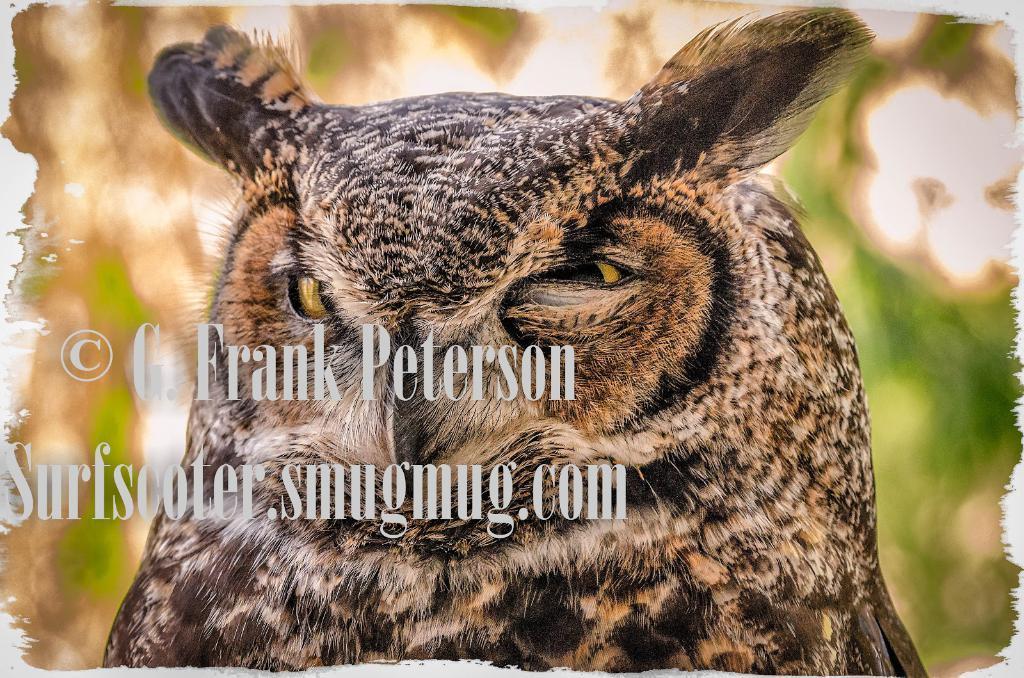Please provide a concise description of this image. This is an edited image. In this image I can see an owl. The background is blurred. On the left side of this image I can see the edited text. 